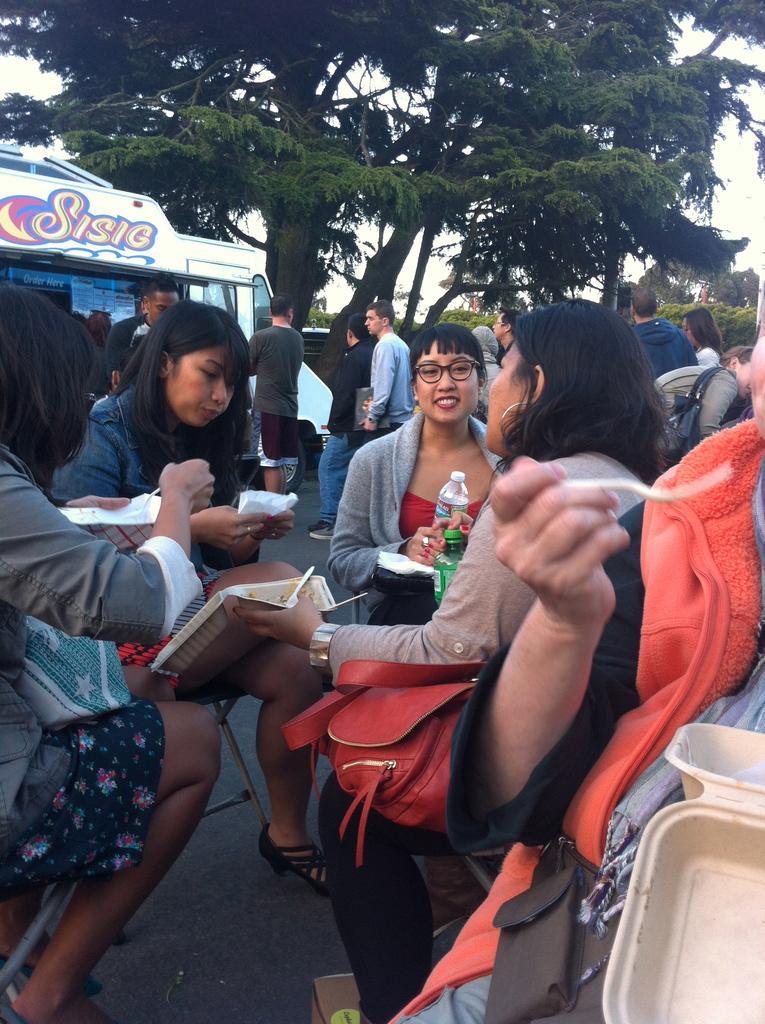In one or two sentences, can you explain what this image depicts? As we can see in the image there are few people here and there sitting on chairs, bottle, papers, trees and sky. 